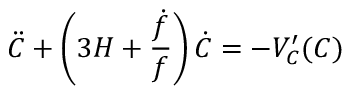Convert formula to latex. <formula><loc_0><loc_0><loc_500><loc_500>\ddot { C } + \left ( 3 H + \frac { \dot { f } } { f } \right ) \dot { C } = - V _ { C } ^ { \prime } ( C )</formula> 